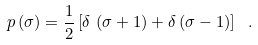<formula> <loc_0><loc_0><loc_500><loc_500>p \left ( \sigma \right ) = \frac { 1 } { 2 } \left [ \delta \, \left ( \sigma + 1 \right ) + \delta \left ( \sigma - 1 \right ) \right ] \ .</formula> 